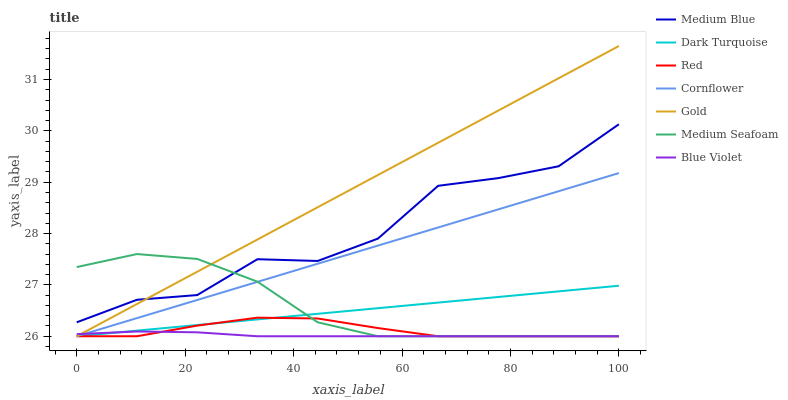Does Dark Turquoise have the minimum area under the curve?
Answer yes or no. No. Does Dark Turquoise have the maximum area under the curve?
Answer yes or no. No. Is Gold the smoothest?
Answer yes or no. No. Is Gold the roughest?
Answer yes or no. No. Does Medium Blue have the lowest value?
Answer yes or no. No. Does Dark Turquoise have the highest value?
Answer yes or no. No. Is Blue Violet less than Medium Blue?
Answer yes or no. Yes. Is Medium Blue greater than Blue Violet?
Answer yes or no. Yes. Does Blue Violet intersect Medium Blue?
Answer yes or no. No. 